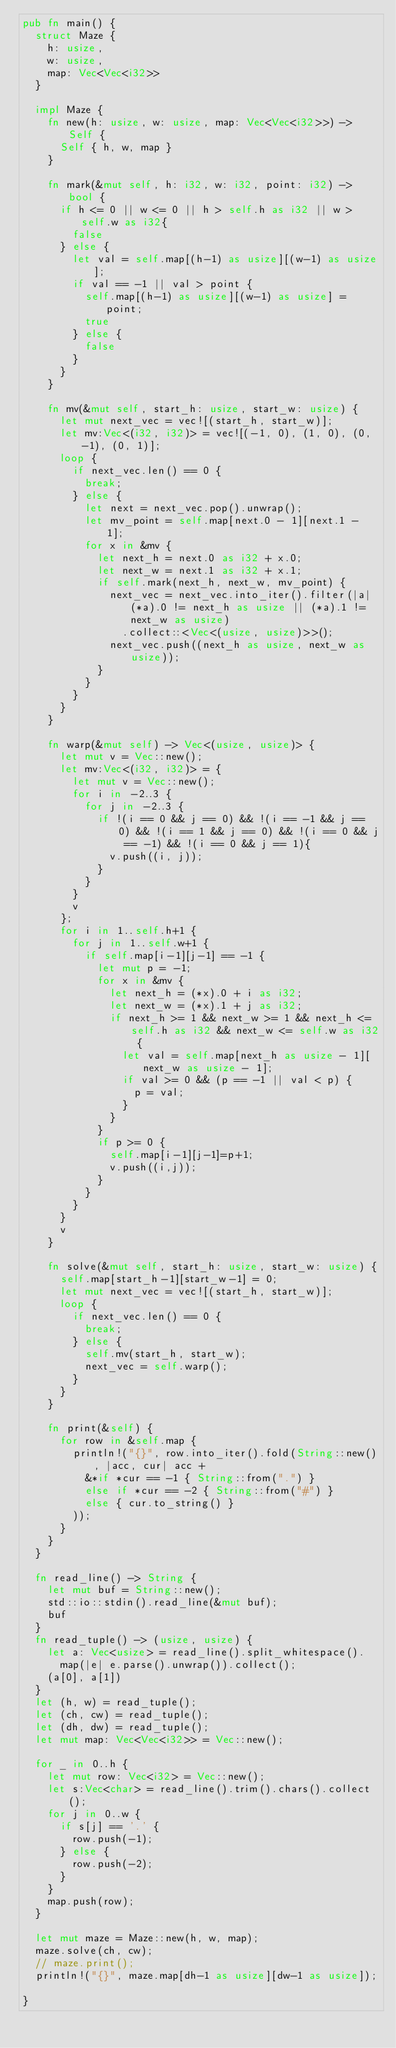<code> <loc_0><loc_0><loc_500><loc_500><_Rust_>pub fn main() {
  struct Maze {
    h: usize,
    w: usize,
    map: Vec<Vec<i32>>
  }

  impl Maze {
    fn new(h: usize, w: usize, map: Vec<Vec<i32>>) -> Self {
      Self { h, w, map }
    }

    fn mark(&mut self, h: i32, w: i32, point: i32) -> bool {
      if h <= 0 || w <= 0 || h > self.h as i32 || w > self.w as i32{
        false
      } else {
        let val = self.map[(h-1) as usize][(w-1) as usize];
        if val == -1 || val > point {
          self.map[(h-1) as usize][(w-1) as usize] = point;
          true
        } else {
          false
        }
      }
    }

    fn mv(&mut self, start_h: usize, start_w: usize) {
      let mut next_vec = vec![(start_h, start_w)];
      let mv:Vec<(i32, i32)> = vec![(-1, 0), (1, 0), (0, -1), (0, 1)];
      loop {
        if next_vec.len() == 0 {
          break;
        } else {
          let next = next_vec.pop().unwrap();
          let mv_point = self.map[next.0 - 1][next.1 - 1];
          for x in &mv {
            let next_h = next.0 as i32 + x.0;
            let next_w = next.1 as i32 + x.1;
            if self.mark(next_h, next_w, mv_point) {
              next_vec = next_vec.into_iter().filter(|a| (*a).0 != next_h as usize || (*a).1 != next_w as usize)
                .collect::<Vec<(usize, usize)>>();
              next_vec.push((next_h as usize, next_w as usize));
            }
          }
        }
      }
    }

    fn warp(&mut self) -> Vec<(usize, usize)> {
      let mut v = Vec::new();
      let mv:Vec<(i32, i32)> = {
        let mut v = Vec::new();
        for i in -2..3 {
          for j in -2..3 {
            if !(i == 0 && j == 0) && !(i == -1 && j == 0) && !(i == 1 && j == 0) && !(i == 0 && j == -1) && !(i == 0 && j == 1){
              v.push((i, j));
            }
          }
        }
        v
      };
      for i in 1..self.h+1 {
        for j in 1..self.w+1 {
          if self.map[i-1][j-1] == -1 {
            let mut p = -1;
            for x in &mv {
              let next_h = (*x).0 + i as i32;
              let next_w = (*x).1 + j as i32;
              if next_h >= 1 && next_w >= 1 && next_h <= self.h as i32 && next_w <= self.w as i32 {
                let val = self.map[next_h as usize - 1][next_w as usize - 1];
                if val >= 0 && (p == -1 || val < p) {
                  p = val;
                }
              }
            }
            if p >= 0 {
              self.map[i-1][j-1]=p+1;
              v.push((i,j));
            }
          }
        }
      }
      v
    }

    fn solve(&mut self, start_h: usize, start_w: usize) {
      self.map[start_h-1][start_w-1] = 0;
      let mut next_vec = vec![(start_h, start_w)];
      loop {
        if next_vec.len() == 0 {
          break;
        } else {
          self.mv(start_h, start_w);
          next_vec = self.warp();
        }
      }
    }

    fn print(&self) {
      for row in &self.map {
        println!("{}", row.into_iter().fold(String::new(), |acc, cur| acc +
          &*if *cur == -1 { String::from(".") }
          else if *cur == -2 { String::from("#") }
          else { cur.to_string() }
        ));
      }
    }
  }

  fn read_line() -> String {
    let mut buf = String::new();
    std::io::stdin().read_line(&mut buf);
    buf
  }
  fn read_tuple() -> (usize, usize) {
    let a: Vec<usize> = read_line().split_whitespace().
      map(|e| e.parse().unwrap()).collect();
    (a[0], a[1])
  }
  let (h, w) = read_tuple();
  let (ch, cw) = read_tuple();
  let (dh, dw) = read_tuple();
  let mut map: Vec<Vec<i32>> = Vec::new();

  for _ in 0..h {
    let mut row: Vec<i32> = Vec::new();
    let s:Vec<char> = read_line().trim().chars().collect();
    for j in 0..w {
      if s[j] == '.' {
        row.push(-1);
      } else {
        row.push(-2);
      }
    }
    map.push(row);
  }

  let mut maze = Maze::new(h, w, map);
  maze.solve(ch, cw);
  // maze.print();
  println!("{}", maze.map[dh-1 as usize][dw-1 as usize]);

}
</code> 